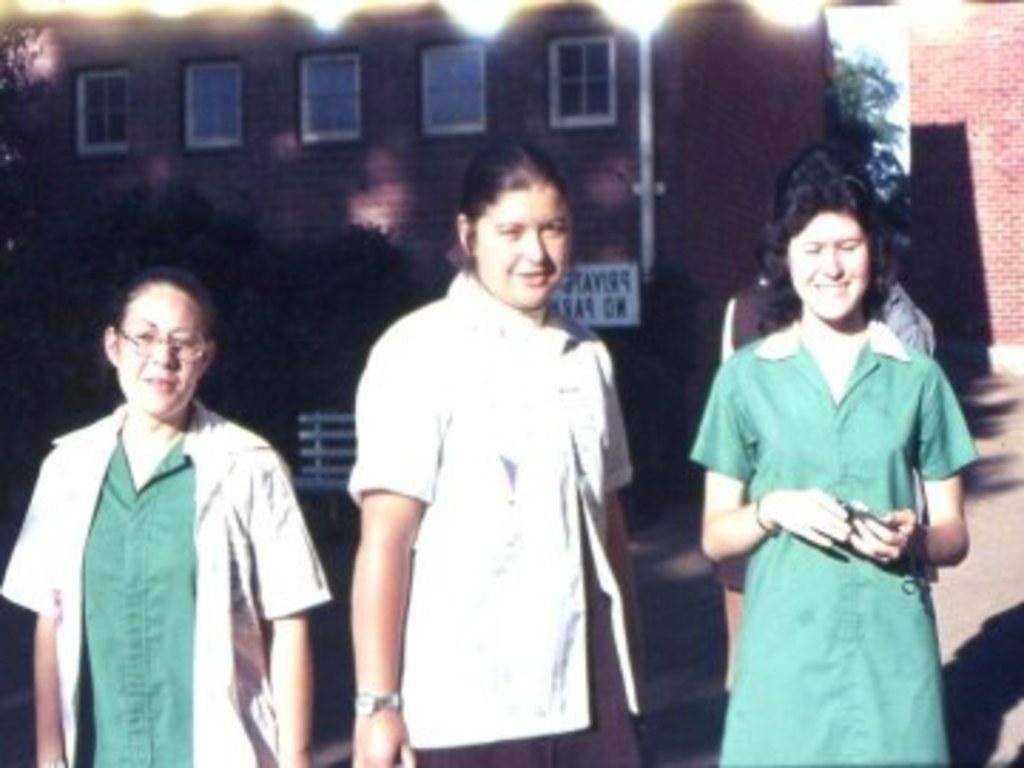How many women are present in the image? There are three women in the image. Where are the women located in the image? The women are at the bottom of the image. What can be seen in the background of the image? There are trees and a building in the background of the image. What type of land is visible in the image? There is no specific type of land mentioned or visible in the image. What kind of loaf is being prepared by the women in the image? There is no indication of any food preparation or loaf in the image. 